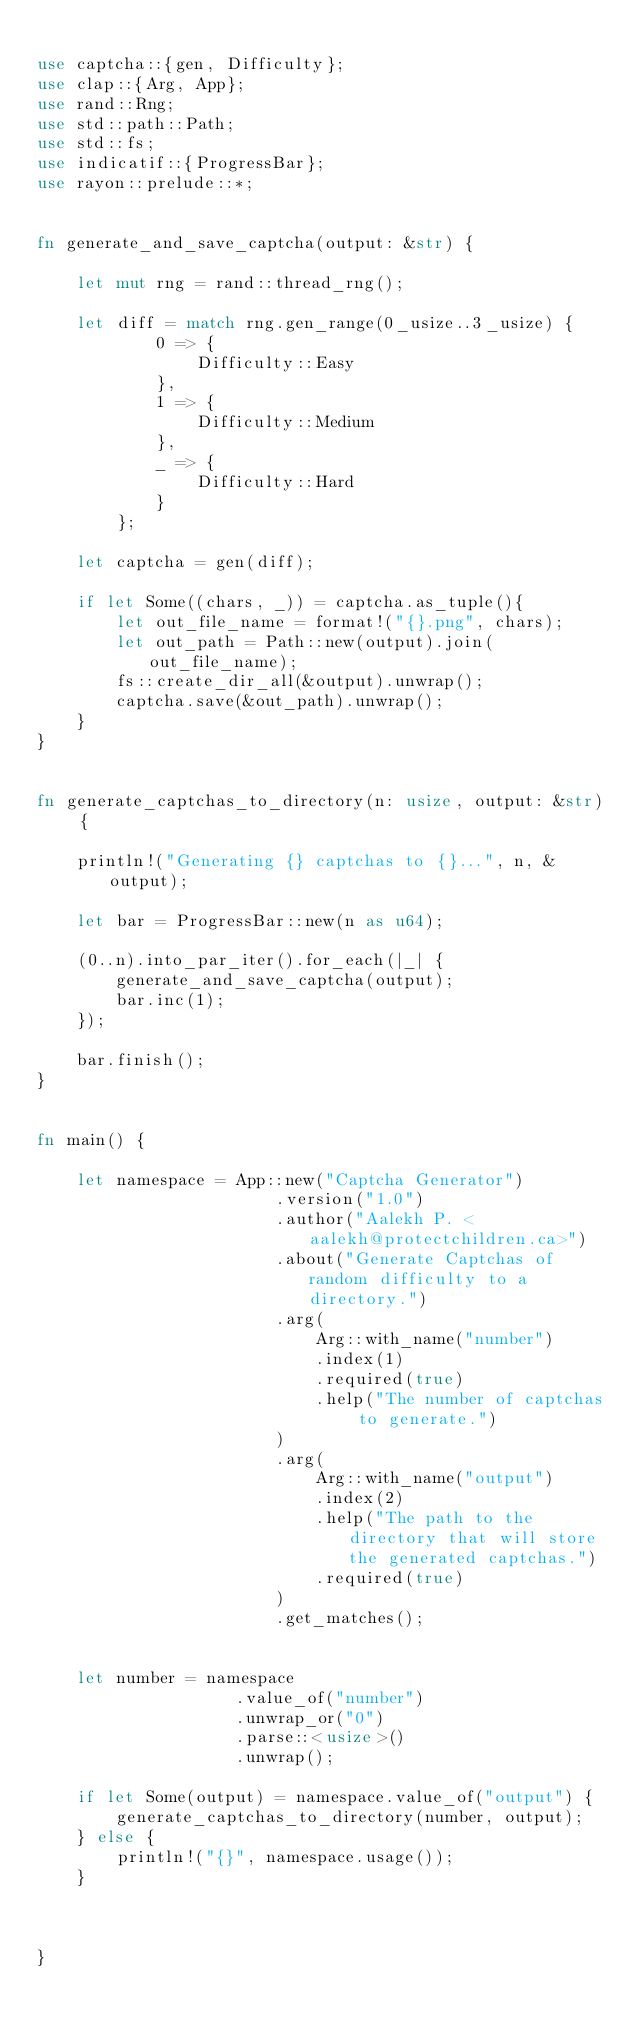Convert code to text. <code><loc_0><loc_0><loc_500><loc_500><_Rust_>
use captcha::{gen, Difficulty};
use clap::{Arg, App};
use rand::Rng;
use std::path::Path;
use std::fs;
use indicatif::{ProgressBar};
use rayon::prelude::*;


fn generate_and_save_captcha(output: &str) {

    let mut rng = rand::thread_rng();

    let diff = match rng.gen_range(0_usize..3_usize) {
            0 => {
                Difficulty::Easy
            },
            1 => {
                Difficulty::Medium
            },
            _ => {
                Difficulty::Hard
            }    
        };

    let captcha = gen(diff);

    if let Some((chars, _)) = captcha.as_tuple(){
        let out_file_name = format!("{}.png", chars);
        let out_path = Path::new(output).join(out_file_name);
        fs::create_dir_all(&output).unwrap();
        captcha.save(&out_path).unwrap();
    }
}


fn generate_captchas_to_directory(n: usize, output: &str) {
    
    println!("Generating {} captchas to {}...", n, &output);

    let bar = ProgressBar::new(n as u64);

    (0..n).into_par_iter().for_each(|_| {
        generate_and_save_captcha(output);
        bar.inc(1);
    });

    bar.finish();
}


fn main() {

    let namespace = App::new("Captcha Generator")
                        .version("1.0")
                        .author("Aalekh P. <aalekh@protectchildren.ca>")
                        .about("Generate Captchas of random difficulty to a directory.")
                        .arg(
                            Arg::with_name("number")
                            .index(1)
                            .required(true)
                            .help("The number of captchas to generate.")
                        )
                        .arg(
                            Arg::with_name("output")
                            .index(2)
                            .help("The path to the directory that will store the generated captchas.")
                            .required(true)
                        )
                        .get_matches();


    let number = namespace
                    .value_of("number")
                    .unwrap_or("0")
                    .parse::<usize>()
                    .unwrap();

    if let Some(output) = namespace.value_of("output") {
        generate_captchas_to_directory(number, output);
    } else {
        println!("{}", namespace.usage());
    }



}
</code> 